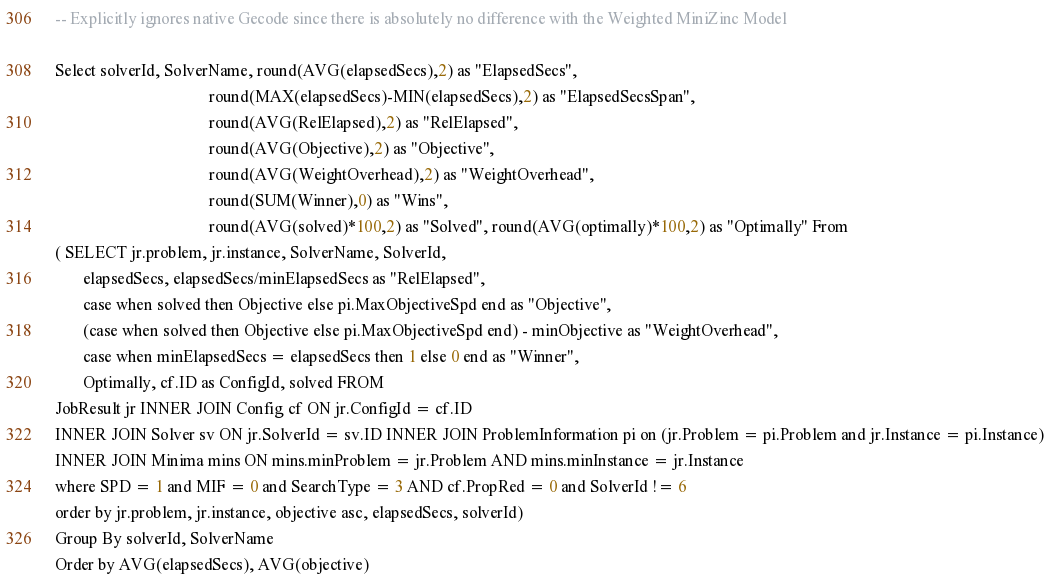<code> <loc_0><loc_0><loc_500><loc_500><_SQL_>-- Explicitly ignores native Gecode since there is absolutely no difference with the Weighted MiniZinc Model

Select solverId, SolverName, round(AVG(elapsedSecs),2) as "ElapsedSecs", 
                                      round(MAX(elapsedSecs)-MIN(elapsedSecs),2) as "ElapsedSecsSpan",
									  round(AVG(RelElapsed),2) as "RelElapsed",
                                      round(AVG(Objective),2) as "Objective", 
									  round(AVG(WeightOverhead),2) as "WeightOverhead", 
									  round(SUM(Winner),0) as "Wins",
									  round(AVG(solved)*100,2) as "Solved", round(AVG(optimally)*100,2) as "Optimally" From
( SELECT jr.problem, jr.instance, SolverName, SolverId, 
       elapsedSecs, elapsedSecs/minElapsedSecs as "RelElapsed", 
       case when solved then Objective else pi.MaxObjectiveSpd end as "Objective", 
	   (case when solved then Objective else pi.MaxObjectiveSpd end) - minObjective as "WeightOverhead",
	   case when minElapsedSecs = elapsedSecs then 1 else 0 end as "Winner",
	   Optimally, cf.ID as ConfigId, solved FROM 
JobResult jr INNER JOIN Config cf ON jr.ConfigId = cf.ID 
INNER JOIN Solver sv ON jr.SolverId = sv.ID INNER JOIN ProblemInformation pi on (jr.Problem = pi.Problem and jr.Instance = pi.Instance)
INNER JOIN Minima mins ON mins.minProblem = jr.Problem AND mins.minInstance = jr.Instance
where SPD = 1 and MIF = 0 and SearchType = 3 AND cf.PropRed = 0 and SolverId != 6
order by jr.problem, jr.instance, objective asc, elapsedSecs, solverId)
Group By solverId, SolverName
Order by AVG(elapsedSecs), AVG(objective)</code> 